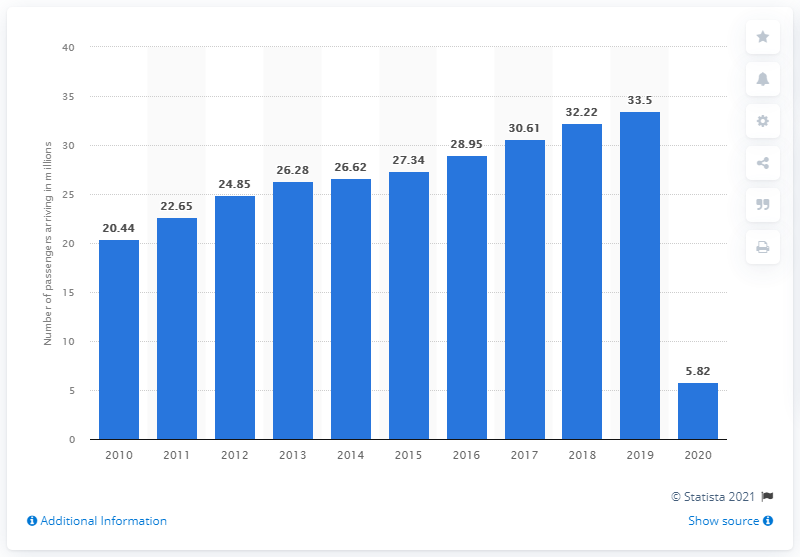Identify some key points in this picture. A total of 5,820 people left Singaporean Changi Airport in 2020. In the year 2020, 5.8 million people departed from Singaporean Changi Airport. 